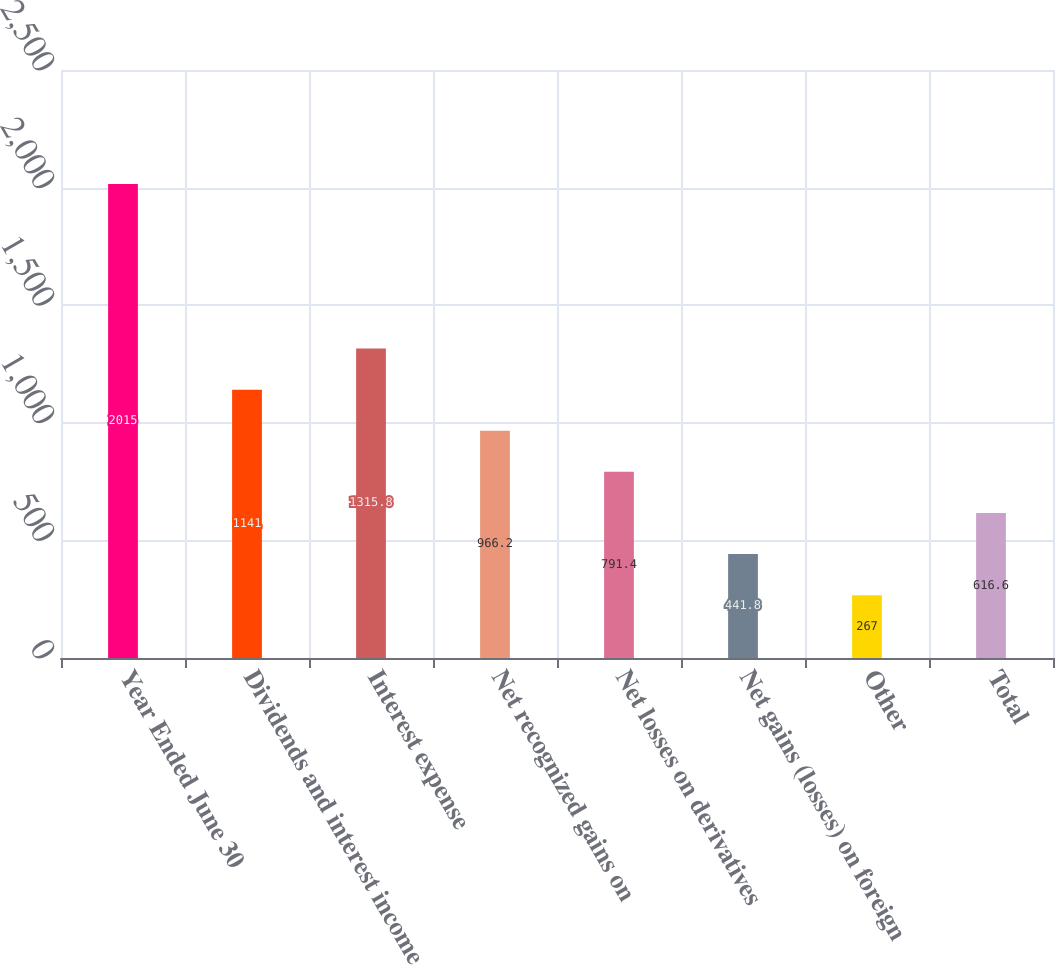Convert chart to OTSL. <chart><loc_0><loc_0><loc_500><loc_500><bar_chart><fcel>Year Ended June 30<fcel>Dividends and interest income<fcel>Interest expense<fcel>Net recognized gains on<fcel>Net losses on derivatives<fcel>Net gains (losses) on foreign<fcel>Other<fcel>Total<nl><fcel>2015<fcel>1141<fcel>1315.8<fcel>966.2<fcel>791.4<fcel>441.8<fcel>267<fcel>616.6<nl></chart> 